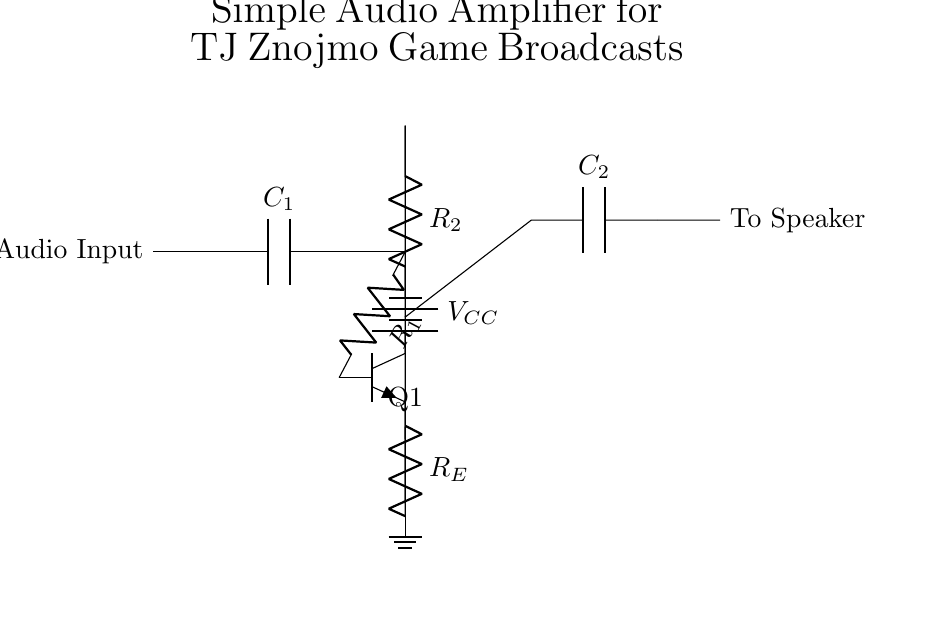What component is used for audio input? The circuit diagram shows that a capacitor, labeled C1, is used for the audio input, indicating the AC coupling of the audio signal.
Answer: Capacitor What is the biasing voltage in the circuit? The biasing voltage is provided by a battery labeled VCC, indicating the required voltage for transistor operation.
Answer: VCC What is the purpose of resistor R1? Resistor R1 connects to the base of the transistor, helping to control the base current, which allows the transistor to amplify the audio signal.
Answer: Base current control How many capacitors are present in this circuit? Observing the circuit diagram, there are two capacitors: C1 for the input and C2 for the output.
Answer: Two What is the function of the transistor in the circuit? The transistor acts as an amplifier, increasing the strength of the audio signal by using the biasing voltage and the input audio.
Answer: Amplifier What type of transistor is used in this circuit? The diagram indicates an NPN type transistor, which is commonly used in audio amplification circuits for its current gain properties.
Answer: NPN What does the output connect to? The output of the circuit, after passing through capacitor C2, is directed to a speaker, indicating the final stage of delivering the amplified audio.
Answer: Speaker 